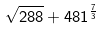Convert formula to latex. <formula><loc_0><loc_0><loc_500><loc_500>\sqrt { 2 8 8 } + 4 8 1 ^ { \frac { 7 } { 3 } }</formula> 